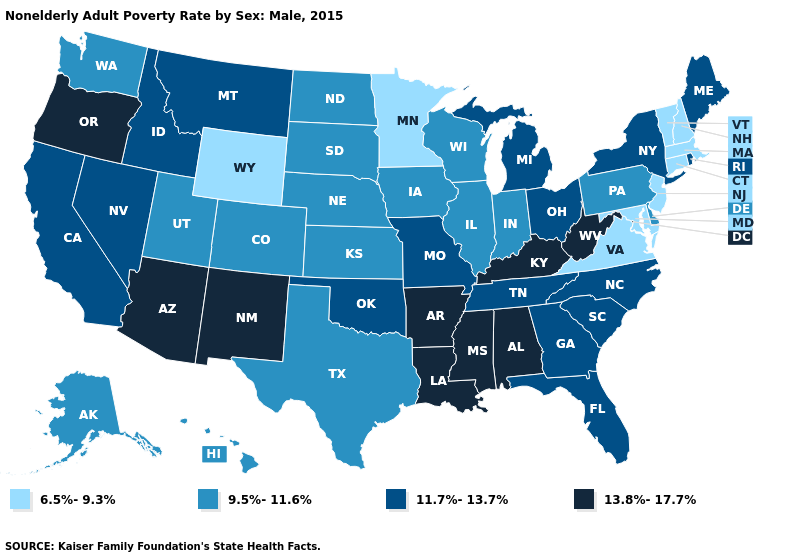Does West Virginia have a higher value than New Mexico?
Give a very brief answer. No. What is the highest value in the West ?
Short answer required. 13.8%-17.7%. What is the lowest value in the South?
Answer briefly. 6.5%-9.3%. What is the value of Nevada?
Concise answer only. 11.7%-13.7%. How many symbols are there in the legend?
Quick response, please. 4. What is the value of Louisiana?
Quick response, please. 13.8%-17.7%. What is the value of North Dakota?
Quick response, please. 9.5%-11.6%. Name the states that have a value in the range 6.5%-9.3%?
Concise answer only. Connecticut, Maryland, Massachusetts, Minnesota, New Hampshire, New Jersey, Vermont, Virginia, Wyoming. Does California have a higher value than Alaska?
Be succinct. Yes. What is the highest value in the USA?
Keep it brief. 13.8%-17.7%. What is the value of Virginia?
Give a very brief answer. 6.5%-9.3%. Does Rhode Island have the lowest value in the USA?
Concise answer only. No. Name the states that have a value in the range 6.5%-9.3%?
Give a very brief answer. Connecticut, Maryland, Massachusetts, Minnesota, New Hampshire, New Jersey, Vermont, Virginia, Wyoming. Name the states that have a value in the range 13.8%-17.7%?
Answer briefly. Alabama, Arizona, Arkansas, Kentucky, Louisiana, Mississippi, New Mexico, Oregon, West Virginia. 